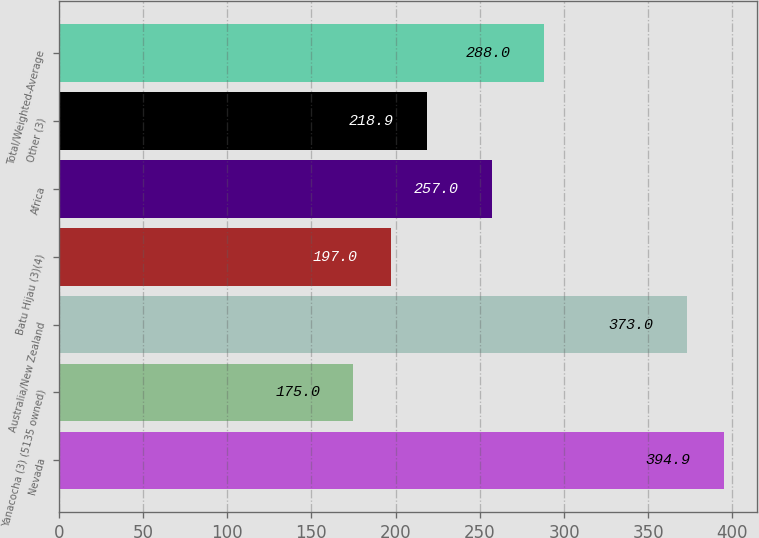Convert chart. <chart><loc_0><loc_0><loc_500><loc_500><bar_chart><fcel>Nevada<fcel>Yanacocha (3) (5135 owned)<fcel>Australia/New Zealand<fcel>Batu Hijau (3)(4)<fcel>Africa<fcel>Other (3)<fcel>Total/Weighted-Average<nl><fcel>394.9<fcel>175<fcel>373<fcel>197<fcel>257<fcel>218.9<fcel>288<nl></chart> 